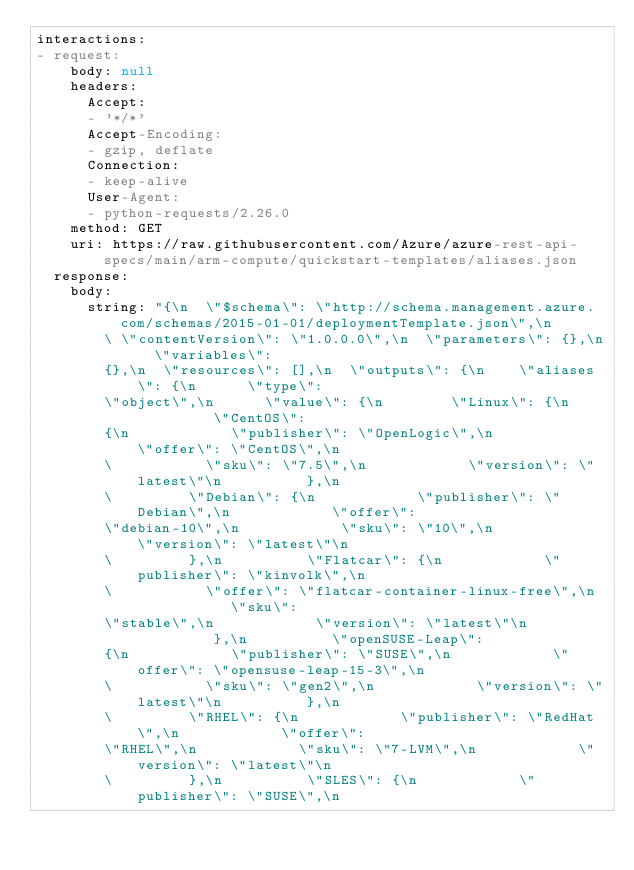Convert code to text. <code><loc_0><loc_0><loc_500><loc_500><_YAML_>interactions:
- request:
    body: null
    headers:
      Accept:
      - '*/*'
      Accept-Encoding:
      - gzip, deflate
      Connection:
      - keep-alive
      User-Agent:
      - python-requests/2.26.0
    method: GET
    uri: https://raw.githubusercontent.com/Azure/azure-rest-api-specs/main/arm-compute/quickstart-templates/aliases.json
  response:
    body:
      string: "{\n  \"$schema\": \"http://schema.management.azure.com/schemas/2015-01-01/deploymentTemplate.json\",\n
        \ \"contentVersion\": \"1.0.0.0\",\n  \"parameters\": {},\n  \"variables\":
        {},\n  \"resources\": [],\n  \"outputs\": {\n    \"aliases\": {\n      \"type\":
        \"object\",\n      \"value\": {\n        \"Linux\": {\n          \"CentOS\":
        {\n            \"publisher\": \"OpenLogic\",\n            \"offer\": \"CentOS\",\n
        \           \"sku\": \"7.5\",\n            \"version\": \"latest\"\n          },\n
        \         \"Debian\": {\n            \"publisher\": \"Debian\",\n            \"offer\":
        \"debian-10\",\n            \"sku\": \"10\",\n            \"version\": \"latest\"\n
        \         },\n          \"Flatcar\": {\n            \"publisher\": \"kinvolk\",\n
        \           \"offer\": \"flatcar-container-linux-free\",\n            \"sku\":
        \"stable\",\n            \"version\": \"latest\"\n          },\n          \"openSUSE-Leap\":
        {\n            \"publisher\": \"SUSE\",\n            \"offer\": \"opensuse-leap-15-3\",\n
        \           \"sku\": \"gen2\",\n            \"version\": \"latest\"\n          },\n
        \         \"RHEL\": {\n            \"publisher\": \"RedHat\",\n            \"offer\":
        \"RHEL\",\n            \"sku\": \"7-LVM\",\n            \"version\": \"latest\"\n
        \         },\n          \"SLES\": {\n            \"publisher\": \"SUSE\",\n</code> 